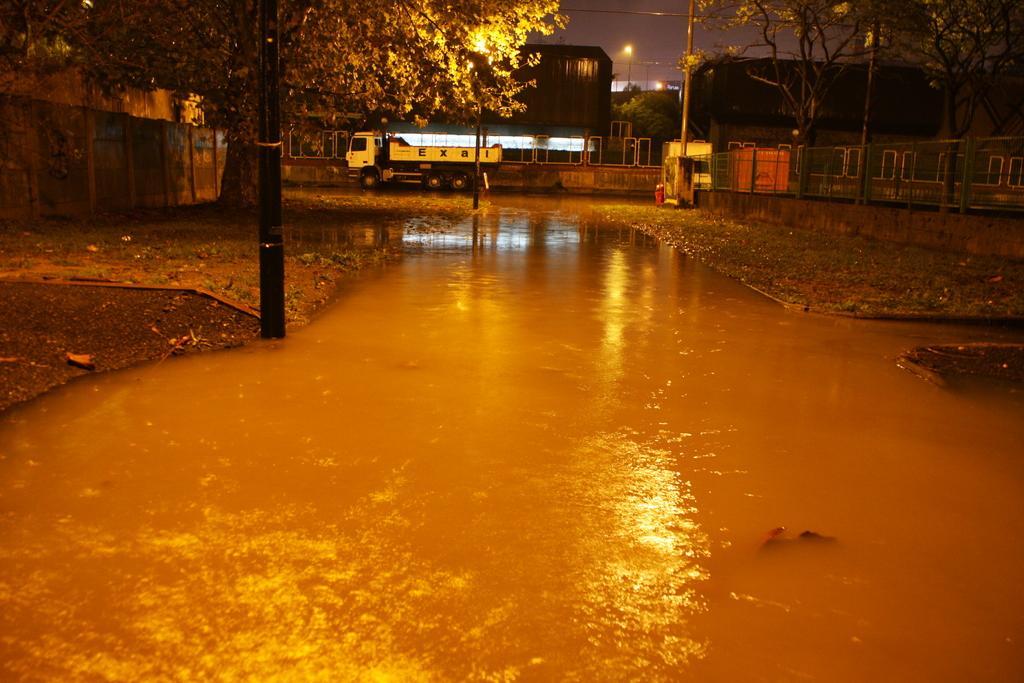Describe this image in one or two sentences. Here in this picture we can see some part of the ground is covered with water all over there and we can see a pole and trees and walls here and there and we can see a truck in the middle and we can see buildings in the far and we can see light posts also present here and there. 